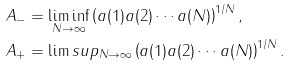Convert formula to latex. <formula><loc_0><loc_0><loc_500><loc_500>A _ { - } & = \liminf _ { N \to \infty } \left ( a ( 1 ) a ( 2 ) \cdots a ( N ) \right ) ^ { 1 / N } , \\ A _ { + } & = \lim s u p _ { N \to \infty } \left ( a ( 1 ) a ( 2 ) \cdots a ( N ) \right ) ^ { 1 / N } .</formula> 